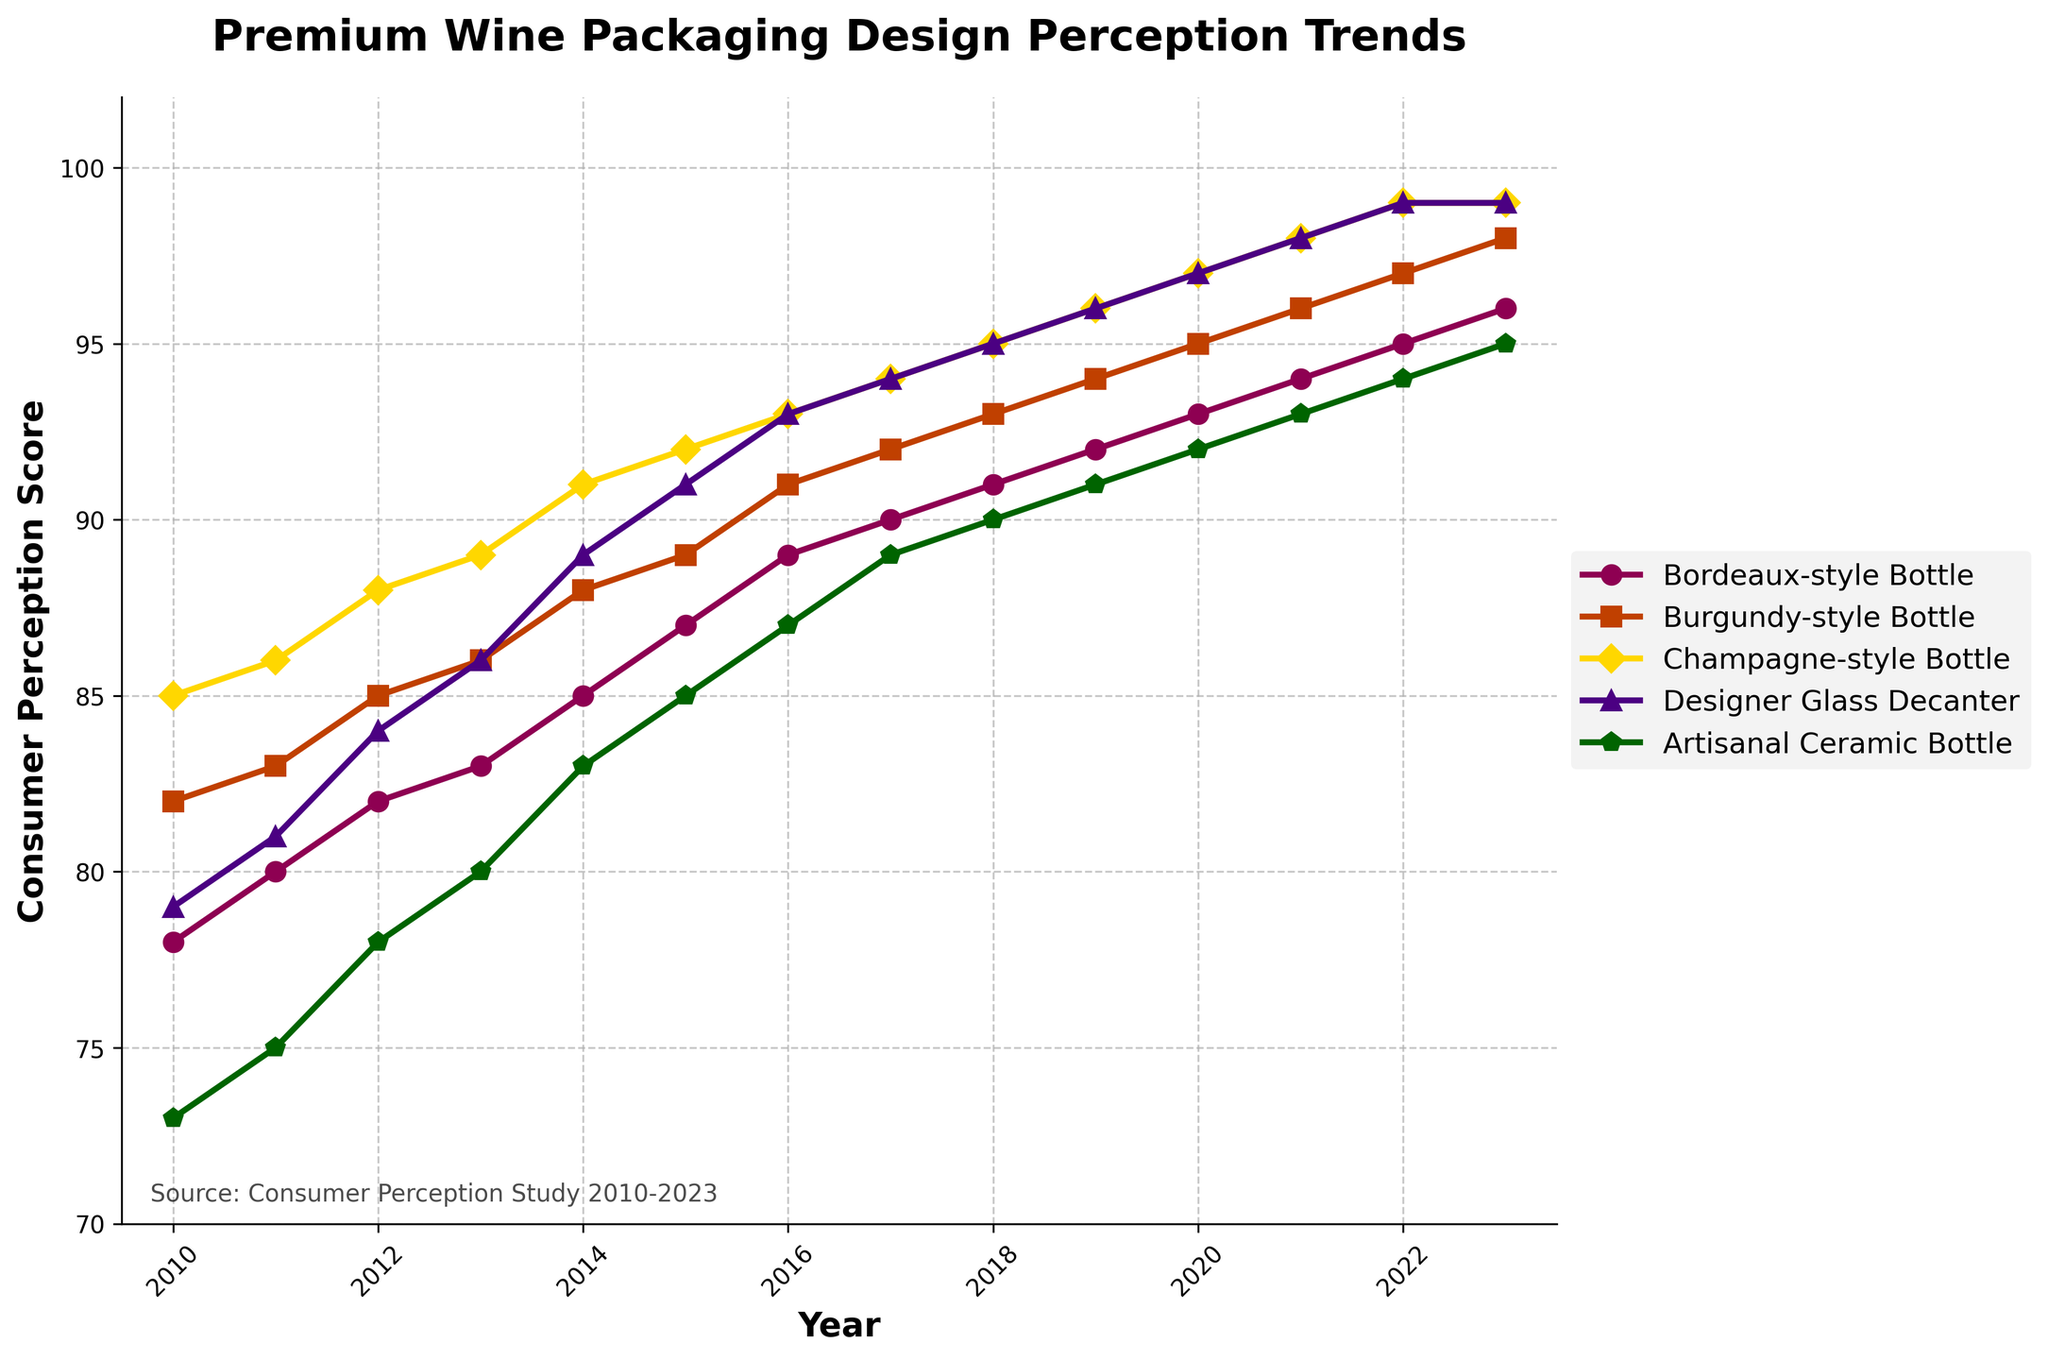What is the highest consumer perception score achieved by the Champagne-style Bottle and in which year? By observing the line representing the Champagne-style Bottle, the maximum score it achieves is 99, and this occurs in the years 2022 and 2023.
Answer: 99, 2022 and 2023 How did the score of the Designer Glass Decanter change from 2015 to 2020? By tracing the line corresponding to Designer Glass Decanter from 2015 to 2020, we can see that the score increased from 91 in 2015 to 97 in 2020, showing a change of +6.
Answer: Increased by 6 Which bottle type had the lowest score in 2010, and what was the score? Looking at the lines for the different bottle types in 2010, the Artisanal Ceramic Bottle has the lowest score at 73.
Answer: Artisanal Ceramic Bottle, 73 What is the difference in consumer perception scores between the Burgundy-style Bottle and Bordeaux-style Bottle in 2013? In 2013, the Burgundy-style Bottle scored 86, while the Bordeaux-style Bottle scored 83. The difference is 86 - 83 = 3.
Answer: 3 Which year shows the biggest increase in score for the Artisanal Ceramic Bottle, and what is the increase? Observing the line for the Artisanal Ceramic Bottle, the most significant increase occurs between 2022 and 2023, with scores rising from 94 to 95. The increase is 1.
Answer: 2023, 1 How many bottle types reached a score of 99 in 2023? By examining the endpoints of all lines for the year 2023, we see that both the Champagne-style Bottle and Designer Glass Decanter reached a score of 99.
Answer: 2 Compare the scores of the Bordeaux-style Bottle and the Designer Glass Decanter in the year 2017. Which one had a higher score and by how much? In 2017, the Bordeaux-style Bottle scored 90, while the Designer Glass Decanter scored 94. The Designer Glass Decanter had a higher score by 94 - 90 = 4.
Answer: Designer Glass Decanter by 4 What was the average consumer perception score for the Burgundy-style Bottle from 2010 to 2015? Summing the scores for the Burgundy-style Bottle from 2010 to 2015: 82 + 83 + 85 + 86 + 88 + 89 = 513. The number of years is 6. The average score is 513 / 6 ≈ 85.5.
Answer: ~85.5 